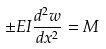<formula> <loc_0><loc_0><loc_500><loc_500>\pm E I \frac { d ^ { 2 } w } { d x ^ { 2 } } = M</formula> 